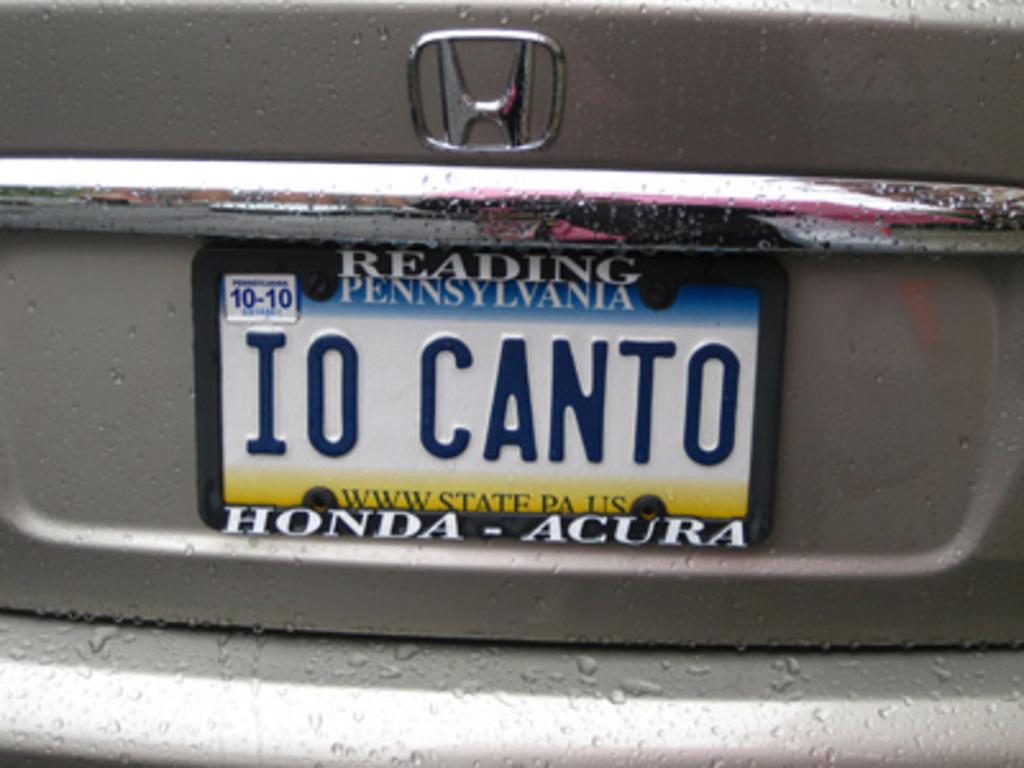What state is this license plate out of?
Ensure brevity in your answer.  Pennsylvania. 